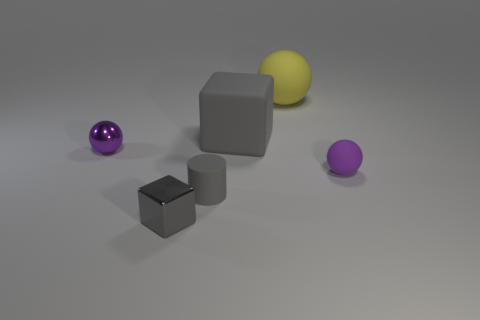Add 4 large gray objects. How many objects exist? 10 Subtract all cylinders. How many objects are left? 5 Add 1 cyan matte cylinders. How many cyan matte cylinders exist? 1 Subtract 0 blue cubes. How many objects are left? 6 Subtract all blue cubes. Subtract all rubber cylinders. How many objects are left? 5 Add 4 metal cubes. How many metal cubes are left? 5 